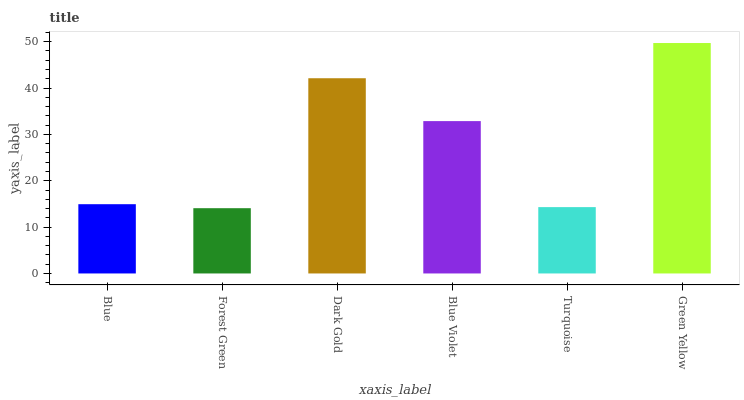Is Forest Green the minimum?
Answer yes or no. Yes. Is Green Yellow the maximum?
Answer yes or no. Yes. Is Dark Gold the minimum?
Answer yes or no. No. Is Dark Gold the maximum?
Answer yes or no. No. Is Dark Gold greater than Forest Green?
Answer yes or no. Yes. Is Forest Green less than Dark Gold?
Answer yes or no. Yes. Is Forest Green greater than Dark Gold?
Answer yes or no. No. Is Dark Gold less than Forest Green?
Answer yes or no. No. Is Blue Violet the high median?
Answer yes or no. Yes. Is Blue the low median?
Answer yes or no. Yes. Is Turquoise the high median?
Answer yes or no. No. Is Green Yellow the low median?
Answer yes or no. No. 